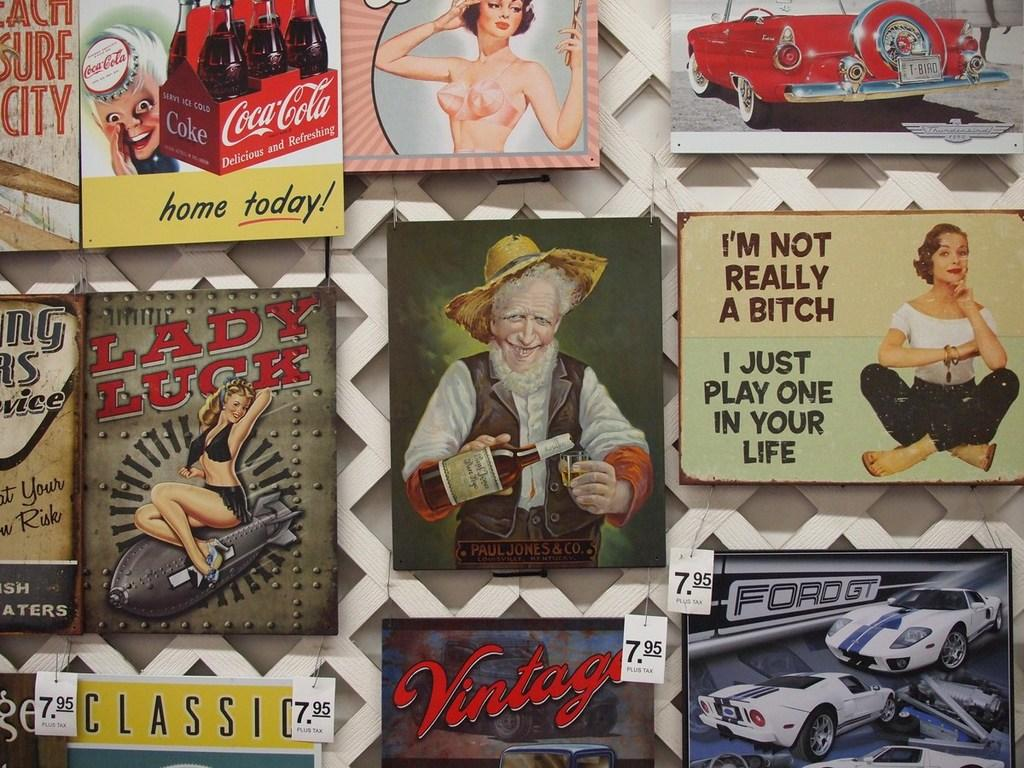What is attached to the fence in the image? There are posters attached to the fence in the image. What types of images are on the posters? The posters contain images of people, vehicles, and bottles. Is there any text on the posters? Yes, text is visible on the posters. How many ants are crawling on the posters in the image? There are no ants present on the posters in the image. What type of card is being used to hold the posters up? There is no card visible in the image; the posters are attached to the fence. 